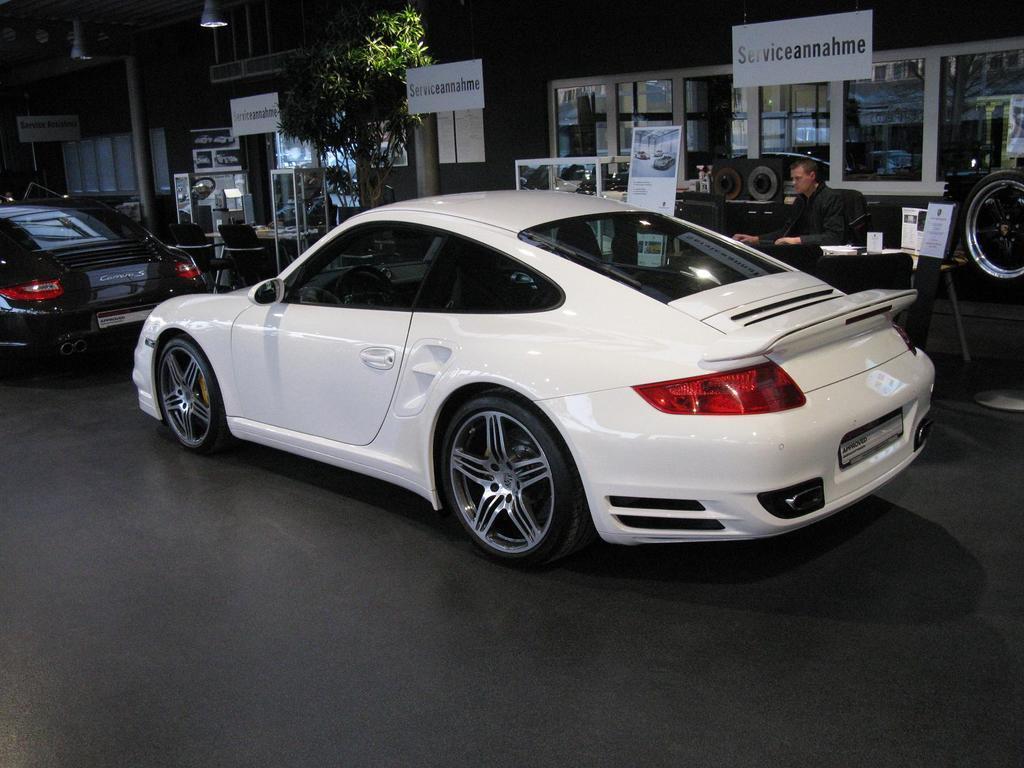Can you describe this image briefly? In the image there is a white car on the road with a black car in front of it and behind there is a man sitting on chair with tables on either side of him with a footpath and behind him there is a building with many windows. 